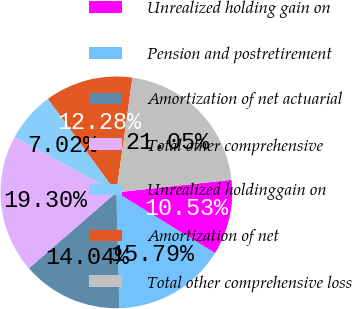<chart> <loc_0><loc_0><loc_500><loc_500><pie_chart><fcel>Unrealized holding gain on<fcel>Pension and postretirement<fcel>Amortization of net actuarial<fcel>Total other comprehensive<fcel>Unrealized holdinggain on<fcel>Amortization of net<fcel>Total other comprehensive loss<nl><fcel>10.53%<fcel>15.79%<fcel>14.04%<fcel>19.3%<fcel>7.02%<fcel>12.28%<fcel>21.05%<nl></chart> 